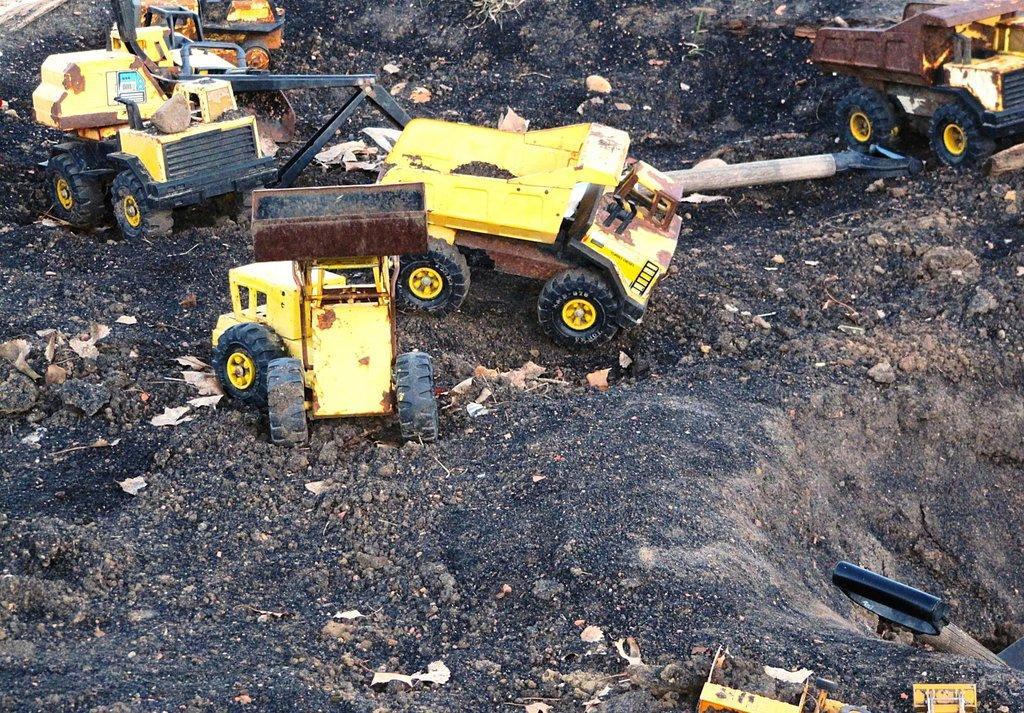Could you give a brief overview of what you see in this image? In this image we can also see group of toy vehicles on the ground ,we can also see some tools. 